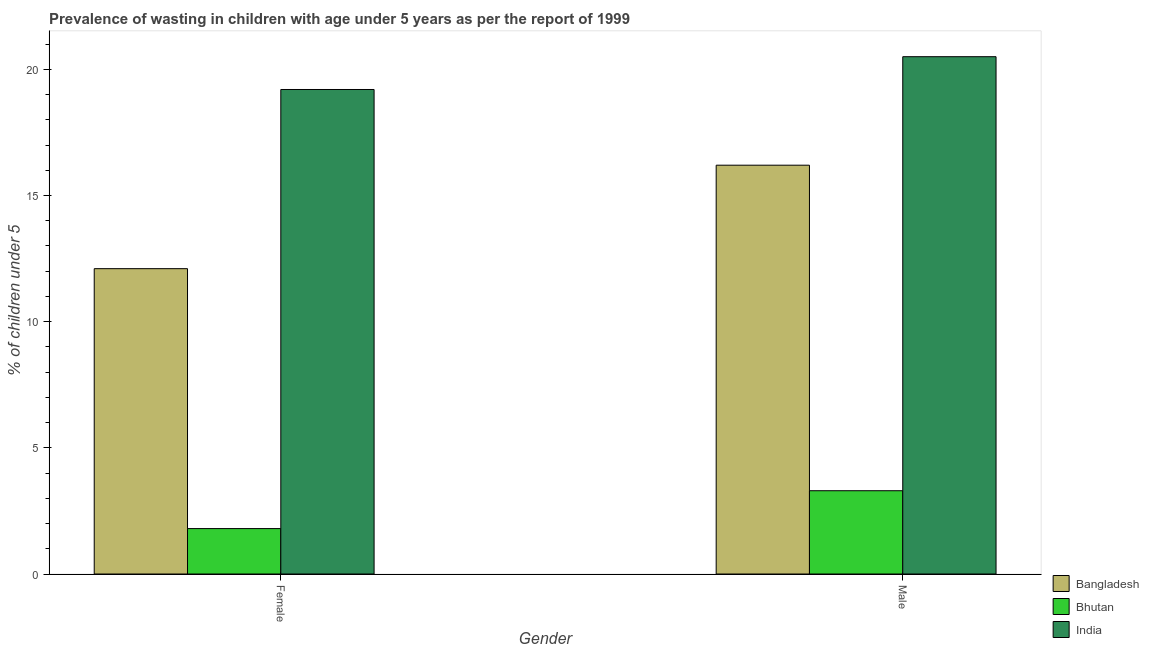Are the number of bars on each tick of the X-axis equal?
Your response must be concise. Yes. How many bars are there on the 2nd tick from the right?
Offer a very short reply. 3. What is the percentage of undernourished male children in Bangladesh?
Make the answer very short. 16.2. Across all countries, what is the minimum percentage of undernourished female children?
Provide a short and direct response. 1.8. In which country was the percentage of undernourished female children minimum?
Provide a succinct answer. Bhutan. What is the total percentage of undernourished female children in the graph?
Keep it short and to the point. 33.1. What is the difference between the percentage of undernourished male children in India and that in Bangladesh?
Keep it short and to the point. 4.3. What is the difference between the percentage of undernourished male children in India and the percentage of undernourished female children in Bhutan?
Your answer should be compact. 18.7. What is the average percentage of undernourished male children per country?
Offer a very short reply. 13.33. What is the difference between the percentage of undernourished female children and percentage of undernourished male children in India?
Your response must be concise. -1.3. In how many countries, is the percentage of undernourished female children greater than 20 %?
Keep it short and to the point. 0. What is the ratio of the percentage of undernourished female children in India to that in Bangladesh?
Your response must be concise. 1.59. In how many countries, is the percentage of undernourished male children greater than the average percentage of undernourished male children taken over all countries?
Your response must be concise. 2. What does the 2nd bar from the left in Male represents?
Keep it short and to the point. Bhutan. How many countries are there in the graph?
Give a very brief answer. 3. What is the difference between two consecutive major ticks on the Y-axis?
Provide a succinct answer. 5. Does the graph contain grids?
Your response must be concise. No. How are the legend labels stacked?
Your response must be concise. Vertical. What is the title of the graph?
Provide a short and direct response. Prevalence of wasting in children with age under 5 years as per the report of 1999. What is the label or title of the X-axis?
Provide a succinct answer. Gender. What is the label or title of the Y-axis?
Your response must be concise.  % of children under 5. What is the  % of children under 5 in Bangladesh in Female?
Give a very brief answer. 12.1. What is the  % of children under 5 of Bhutan in Female?
Make the answer very short. 1.8. What is the  % of children under 5 in India in Female?
Provide a succinct answer. 19.2. What is the  % of children under 5 in Bangladesh in Male?
Ensure brevity in your answer.  16.2. What is the  % of children under 5 in Bhutan in Male?
Your response must be concise. 3.3. What is the  % of children under 5 of India in Male?
Provide a succinct answer. 20.5. Across all Gender, what is the maximum  % of children under 5 in Bangladesh?
Provide a short and direct response. 16.2. Across all Gender, what is the maximum  % of children under 5 of Bhutan?
Your answer should be very brief. 3.3. Across all Gender, what is the maximum  % of children under 5 in India?
Offer a very short reply. 20.5. Across all Gender, what is the minimum  % of children under 5 of Bangladesh?
Make the answer very short. 12.1. Across all Gender, what is the minimum  % of children under 5 in Bhutan?
Your answer should be very brief. 1.8. Across all Gender, what is the minimum  % of children under 5 in India?
Offer a very short reply. 19.2. What is the total  % of children under 5 of Bangladesh in the graph?
Your response must be concise. 28.3. What is the total  % of children under 5 of Bhutan in the graph?
Make the answer very short. 5.1. What is the total  % of children under 5 of India in the graph?
Provide a short and direct response. 39.7. What is the difference between the  % of children under 5 in Bangladesh in Female and that in Male?
Give a very brief answer. -4.1. What is the difference between the  % of children under 5 in Bhutan in Female and that in Male?
Offer a terse response. -1.5. What is the difference between the  % of children under 5 in India in Female and that in Male?
Your response must be concise. -1.3. What is the difference between the  % of children under 5 of Bangladesh in Female and the  % of children under 5 of Bhutan in Male?
Provide a short and direct response. 8.8. What is the difference between the  % of children under 5 of Bhutan in Female and the  % of children under 5 of India in Male?
Give a very brief answer. -18.7. What is the average  % of children under 5 of Bangladesh per Gender?
Keep it short and to the point. 14.15. What is the average  % of children under 5 in Bhutan per Gender?
Your answer should be very brief. 2.55. What is the average  % of children under 5 of India per Gender?
Give a very brief answer. 19.85. What is the difference between the  % of children under 5 of Bhutan and  % of children under 5 of India in Female?
Offer a terse response. -17.4. What is the difference between the  % of children under 5 in Bangladesh and  % of children under 5 in Bhutan in Male?
Keep it short and to the point. 12.9. What is the difference between the  % of children under 5 in Bhutan and  % of children under 5 in India in Male?
Ensure brevity in your answer.  -17.2. What is the ratio of the  % of children under 5 of Bangladesh in Female to that in Male?
Provide a succinct answer. 0.75. What is the ratio of the  % of children under 5 in Bhutan in Female to that in Male?
Offer a terse response. 0.55. What is the ratio of the  % of children under 5 in India in Female to that in Male?
Your answer should be compact. 0.94. What is the difference between the highest and the second highest  % of children under 5 of India?
Your response must be concise. 1.3. What is the difference between the highest and the lowest  % of children under 5 of Bangladesh?
Make the answer very short. 4.1. What is the difference between the highest and the lowest  % of children under 5 of India?
Your response must be concise. 1.3. 